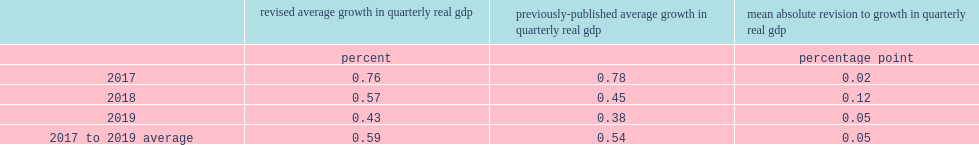What was the mean absolute percentage-point revision to the annual average growth rate of quarterly real gdp for the 2017-to-2019 period? 0.05. Which year's the absolute revision to growth in quarterly real gdp was lowest? 2017.0. Which year's the absolute revision to growth in quarterly real gdp was highest? 2018.0. How many percentage point of the growth rate was revise up in 2019? 0.05. 